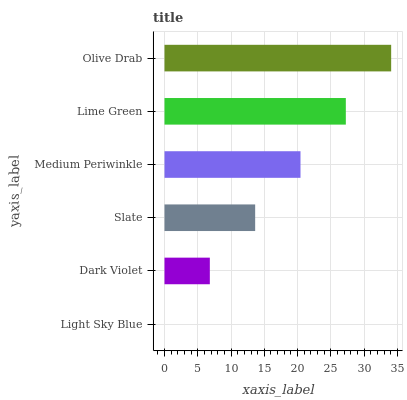Is Light Sky Blue the minimum?
Answer yes or no. Yes. Is Olive Drab the maximum?
Answer yes or no. Yes. Is Dark Violet the minimum?
Answer yes or no. No. Is Dark Violet the maximum?
Answer yes or no. No. Is Dark Violet greater than Light Sky Blue?
Answer yes or no. Yes. Is Light Sky Blue less than Dark Violet?
Answer yes or no. Yes. Is Light Sky Blue greater than Dark Violet?
Answer yes or no. No. Is Dark Violet less than Light Sky Blue?
Answer yes or no. No. Is Medium Periwinkle the high median?
Answer yes or no. Yes. Is Slate the low median?
Answer yes or no. Yes. Is Olive Drab the high median?
Answer yes or no. No. Is Olive Drab the low median?
Answer yes or no. No. 